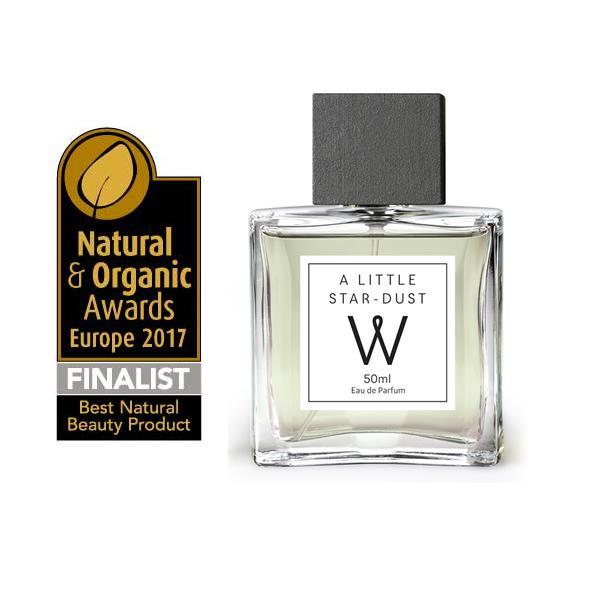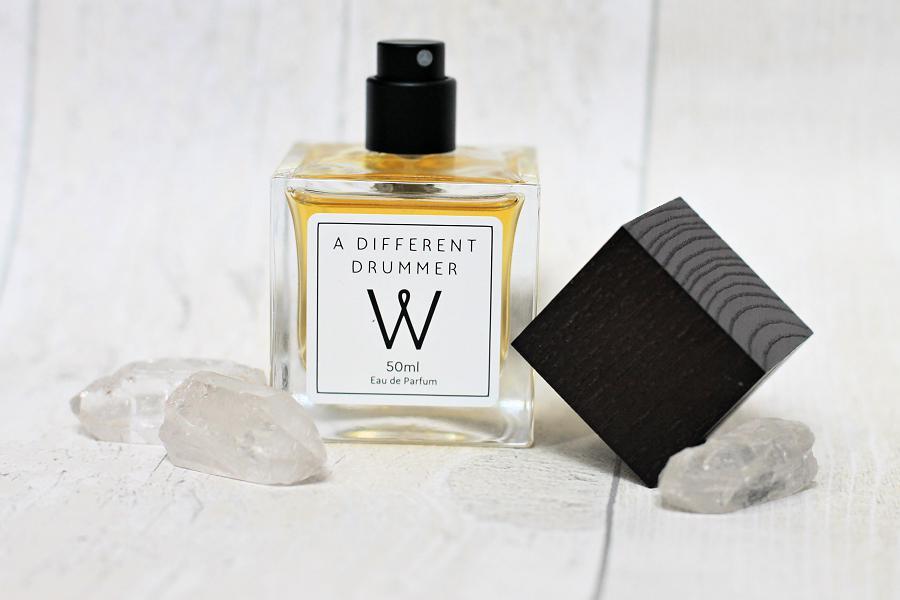The first image is the image on the left, the second image is the image on the right. For the images displayed, is the sentence "In one image, a square shaped spray bottle of cologne has its cap off and positioned to the side of the bottle, while a second image shows a similar square bottle with the cap on." factually correct? Answer yes or no. Yes. The first image is the image on the left, the second image is the image on the right. Analyze the images presented: Is the assertion "A pink flower is on the left of an image containing a square bottled fragrance and its upright box." valid? Answer yes or no. No. 